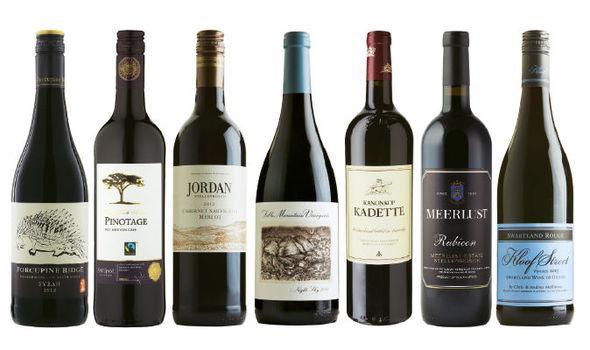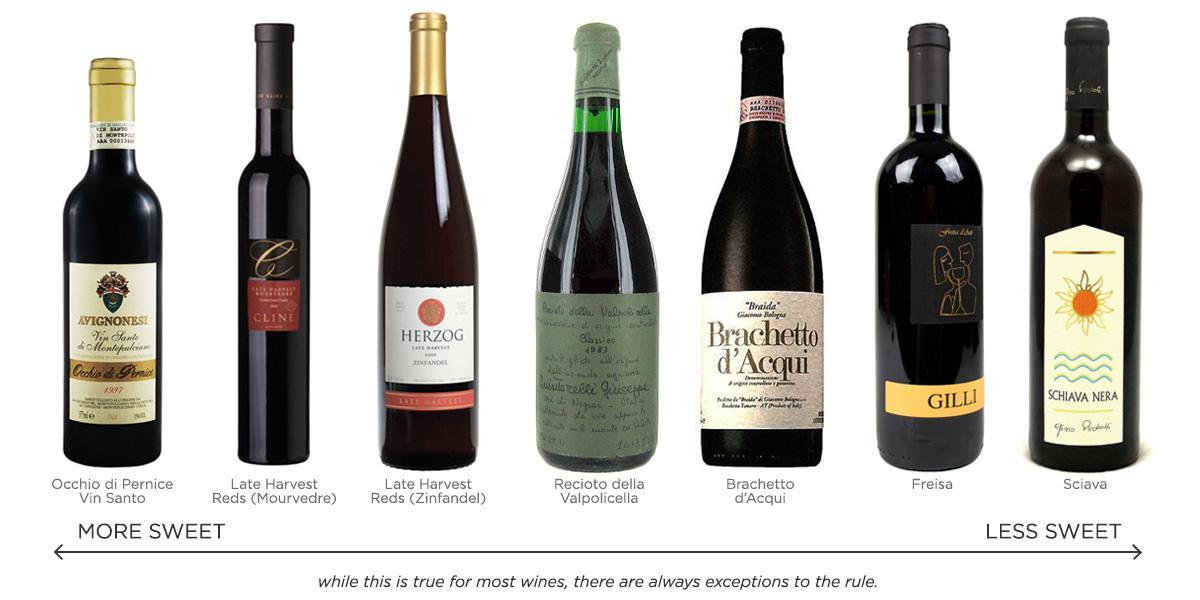The first image is the image on the left, the second image is the image on the right. For the images shown, is this caption "Seven different unopened bottles of wine are lined up in each image." true? Answer yes or no. Yes. 